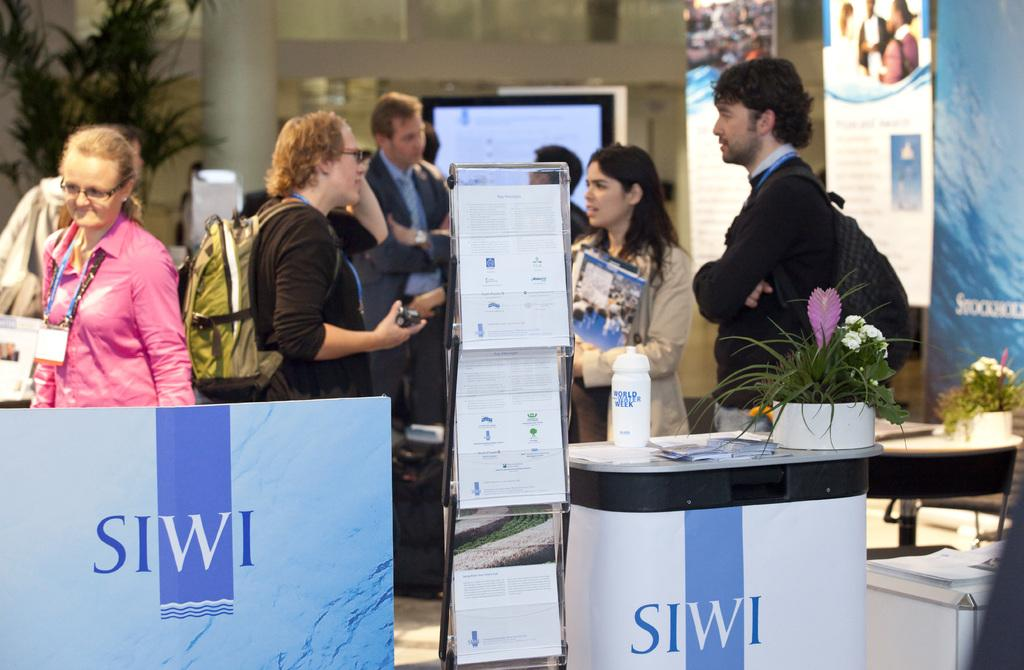<image>
Describe the image concisely. People speaking in front of a sign that says SIWI on it. 